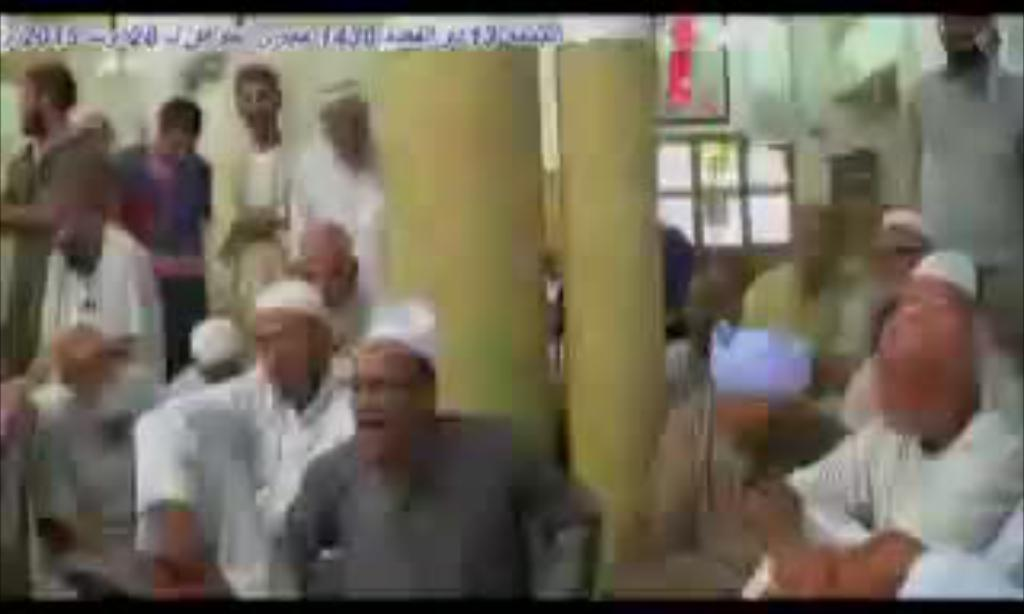Who or what can be seen in the image? There are people in the image. What else is present in the image besides the people? There are objects in the image. Can you describe any text that is visible in the image? Yes, there is text visible on top of the image. What type of ice can be seen melting on the rail in the image? There is no ice or rail present in the image. 